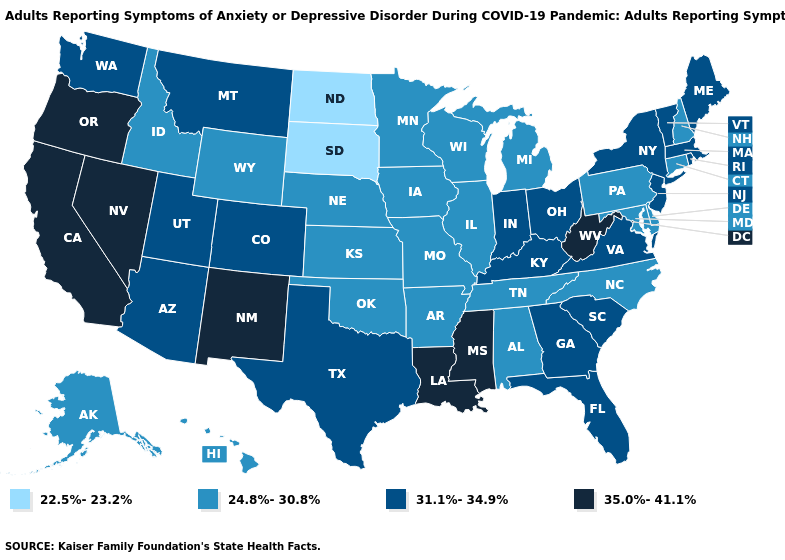How many symbols are there in the legend?
Concise answer only. 4. Name the states that have a value in the range 22.5%-23.2%?
Keep it brief. North Dakota, South Dakota. Name the states that have a value in the range 22.5%-23.2%?
Give a very brief answer. North Dakota, South Dakota. Does the first symbol in the legend represent the smallest category?
Concise answer only. Yes. What is the value of West Virginia?
Concise answer only. 35.0%-41.1%. Name the states that have a value in the range 24.8%-30.8%?
Quick response, please. Alabama, Alaska, Arkansas, Connecticut, Delaware, Hawaii, Idaho, Illinois, Iowa, Kansas, Maryland, Michigan, Minnesota, Missouri, Nebraska, New Hampshire, North Carolina, Oklahoma, Pennsylvania, Tennessee, Wisconsin, Wyoming. What is the value of Mississippi?
Concise answer only. 35.0%-41.1%. Name the states that have a value in the range 24.8%-30.8%?
Be succinct. Alabama, Alaska, Arkansas, Connecticut, Delaware, Hawaii, Idaho, Illinois, Iowa, Kansas, Maryland, Michigan, Minnesota, Missouri, Nebraska, New Hampshire, North Carolina, Oklahoma, Pennsylvania, Tennessee, Wisconsin, Wyoming. What is the lowest value in the USA?
Keep it brief. 22.5%-23.2%. Name the states that have a value in the range 35.0%-41.1%?
Quick response, please. California, Louisiana, Mississippi, Nevada, New Mexico, Oregon, West Virginia. Name the states that have a value in the range 35.0%-41.1%?
Short answer required. California, Louisiana, Mississippi, Nevada, New Mexico, Oregon, West Virginia. What is the value of Massachusetts?
Give a very brief answer. 31.1%-34.9%. Does the first symbol in the legend represent the smallest category?
Give a very brief answer. Yes. Does Arizona have the lowest value in the West?
Concise answer only. No. 